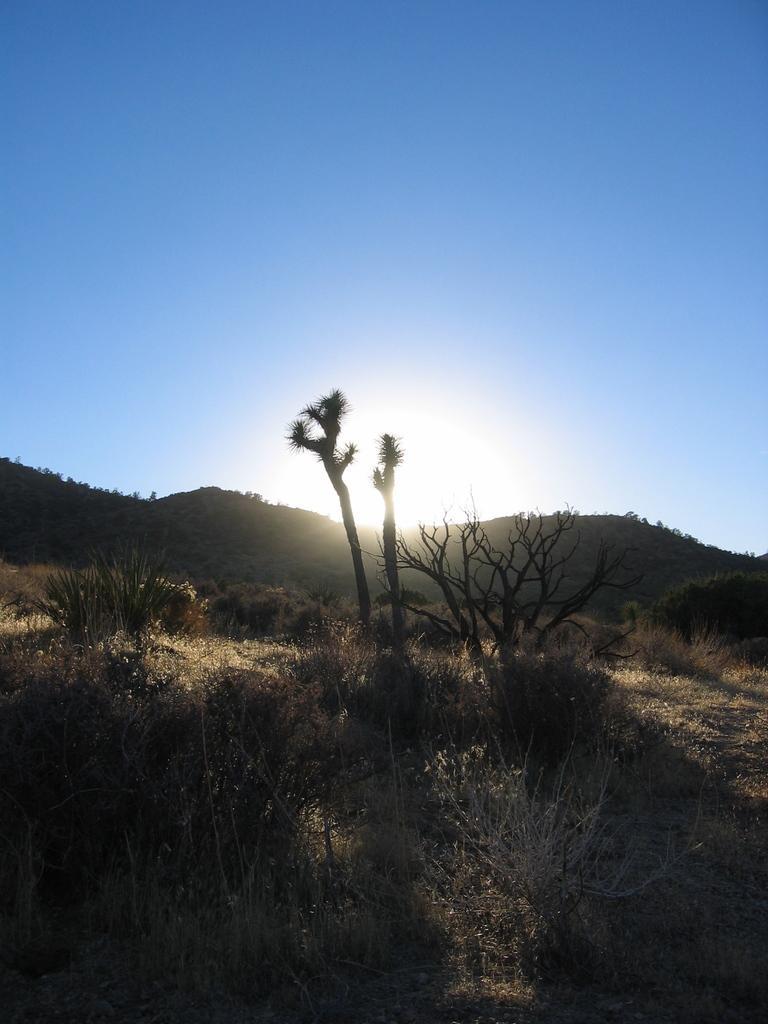In one or two sentences, can you explain what this image depicts? In this picture we can see many trees, plants and grass. In the background we can see mountains and sun. On the top there is a sky. 